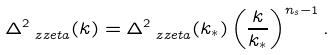<formula> <loc_0><loc_0><loc_500><loc_500>\Delta ^ { 2 } _ { \ z z e t a } ( k ) = \Delta ^ { 2 } _ { \ z z e t a } ( k _ { * } ) \left ( \frac { k } { k _ { * } } \right ) ^ { n _ { s } - 1 } .</formula> 